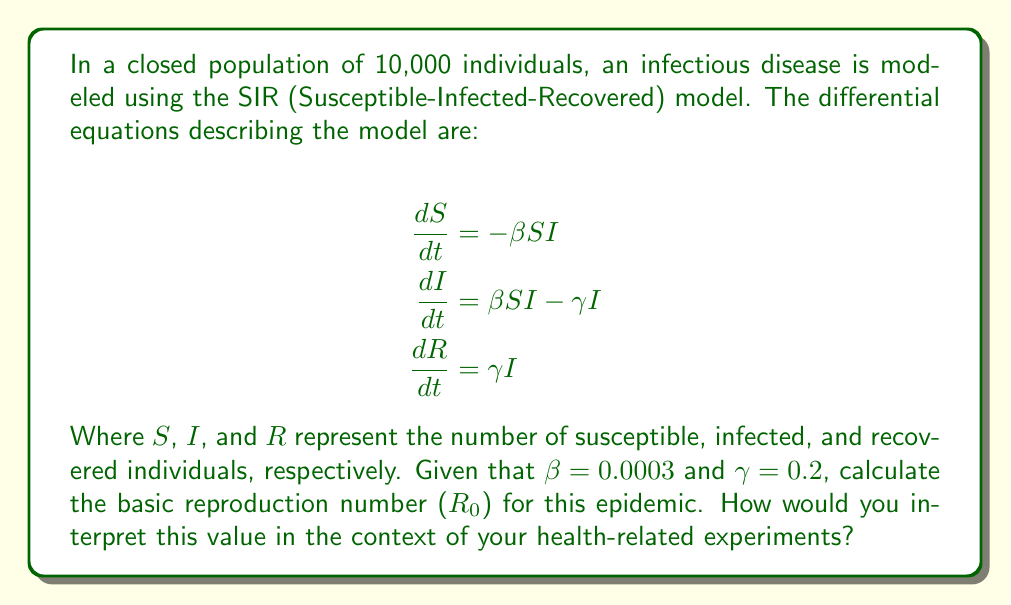Provide a solution to this math problem. To solve this problem, we'll follow these steps:

1. Understand the basic reproduction number ($R_0$):
   $R_0$ is the average number of secondary infections caused by one infected individual in a completely susceptible population.

2. Calculate $R_0$ using the given parameters:
   The formula for $R_0$ in the SIR model is:

   $$R_0 = \frac{\beta N}{\gamma}$$

   Where:
   $\beta$ is the transmission rate
   $N$ is the total population size
   $\gamma$ is the recovery rate

3. Substitute the given values:
   $\beta = 0.0003$
   $N = 10,000$
   $\gamma = 0.2$

4. Perform the calculation:
   $$R_0 = \frac{0.0003 \times 10,000}{0.2} = \frac{3}{2} = 1.5$$

5. Interpret the result:
   - If $R_0 > 1$, the epidemic will spread in the population.
   - If $R_0 < 1$, the epidemic will die out.
   - If $R_0 = 1$, the disease will become endemic.

   In this case, $R_0 = 1.5$, which is greater than 1, indicating that the epidemic will spread in the population.

6. Practical implications for health-related experiments:
   - This $R_0$ value suggests that, on average, each infected person will infect 1.5 others.
   - Interventions should aim to reduce $R_0$ below 1 to control the epidemic.
   - Experiments could focus on strategies to reduce transmission ($\beta$) or increase recovery rate ($\gamma$).
   - Vaccination strategies should aim to immunize at least 1 - (1/$R_0$) = 33.3% of the population to achieve herd immunity.
Answer: $R_0 = 1.5$; epidemic will spread, each infected person infects 1.5 others on average. 